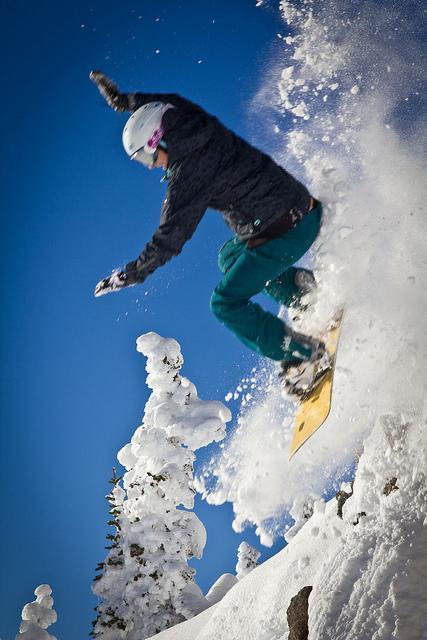How many giraffes are there?
Give a very brief answer. 0. 